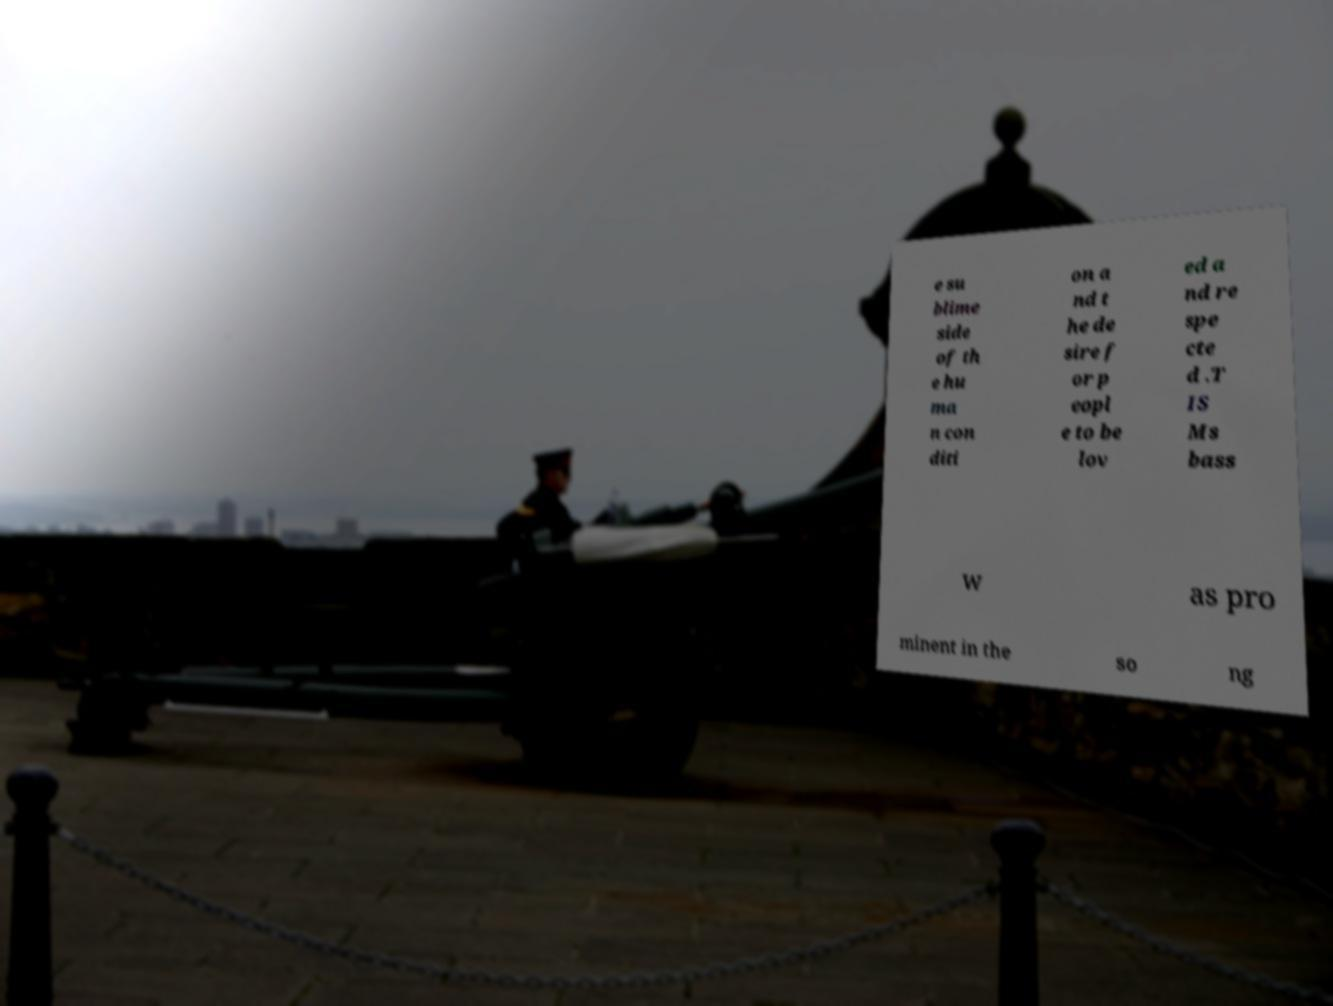Can you read and provide the text displayed in the image?This photo seems to have some interesting text. Can you extract and type it out for me? e su blime side of th e hu ma n con diti on a nd t he de sire f or p eopl e to be lov ed a nd re spe cte d .T IS Ms bass w as pro minent in the so ng 